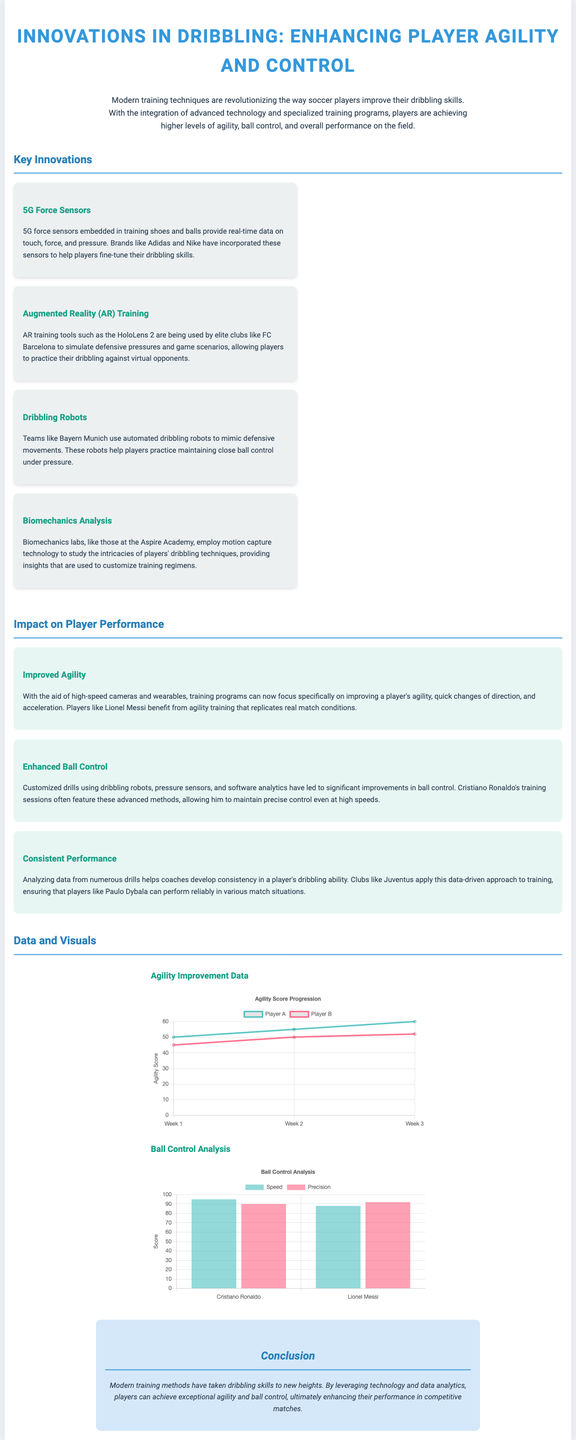What is the title of the document? The title of the document is displayed prominently at the top and summarizes its main focus.
Answer: Innovations in Dribbling: Enhancing Player Agility and Control Which club utilizes Augmented Reality training? The document mentions a specific club known for using AR training tools.
Answer: FC Barcelona What technology is used for analyzing player biomechanics? The document specifies the type of technology that helps in studying player dribbling techniques.
Answer: Motion capture What is the agility score of Player A in Week 3? The agility improvement chart shows Player A's score for that week.
Answer: 60 How many key innovations are listed in the document? The document outlines several innovations, and a specific number is mentioned.
Answer: 4 What is the precision score of Lionel Messi in the Ball Control Analysis? The ball control analysis chart provides numerical scores for players, including Messi.
Answer: 92 Which player's training sessions feature advanced methods for ball control? The document explicitly names a well-known player associated with these training methods.
Answer: Cristiano Ronaldo Which innovation uses automated technology to mimic defensive movements? The document describes a specific technology that assists players in improving their dribbling.
Answer: Dribbling Robots 